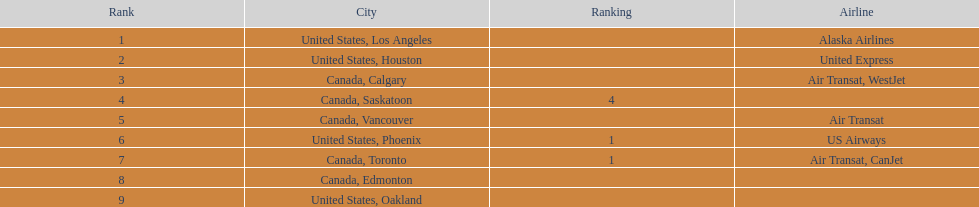Los angeles and which other city had approximately 19,000 passengers combined? Canada, Calgary. 